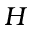<formula> <loc_0><loc_0><loc_500><loc_500>H</formula> 